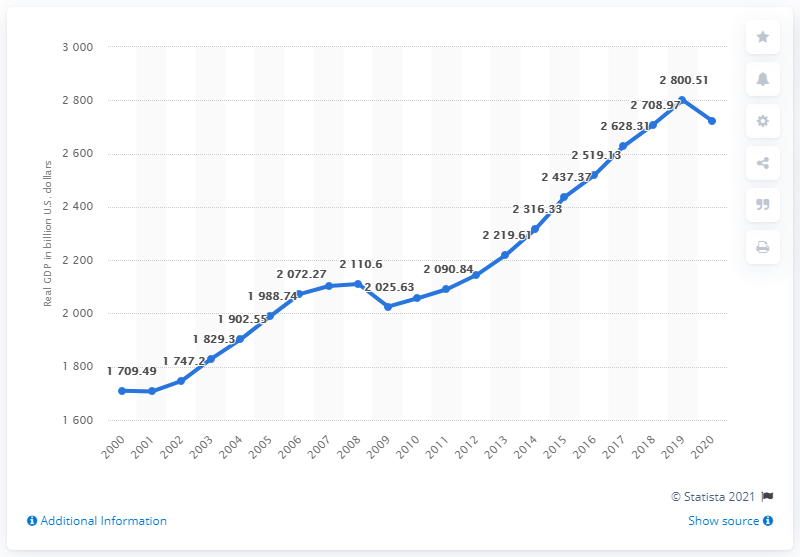List a handful of essential elements in this visual. In 2020, the Gross Domestic Product (GDP) of California was 2722.84. In the previous year, California's GDP was 2800.51.. 